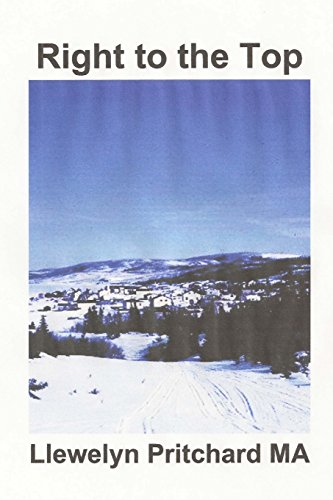What type of book is this? This book is classified under the 'Teen & Young Adult' genre, which suggests it is designed to appeal to young readers with its themes and narrative style. 